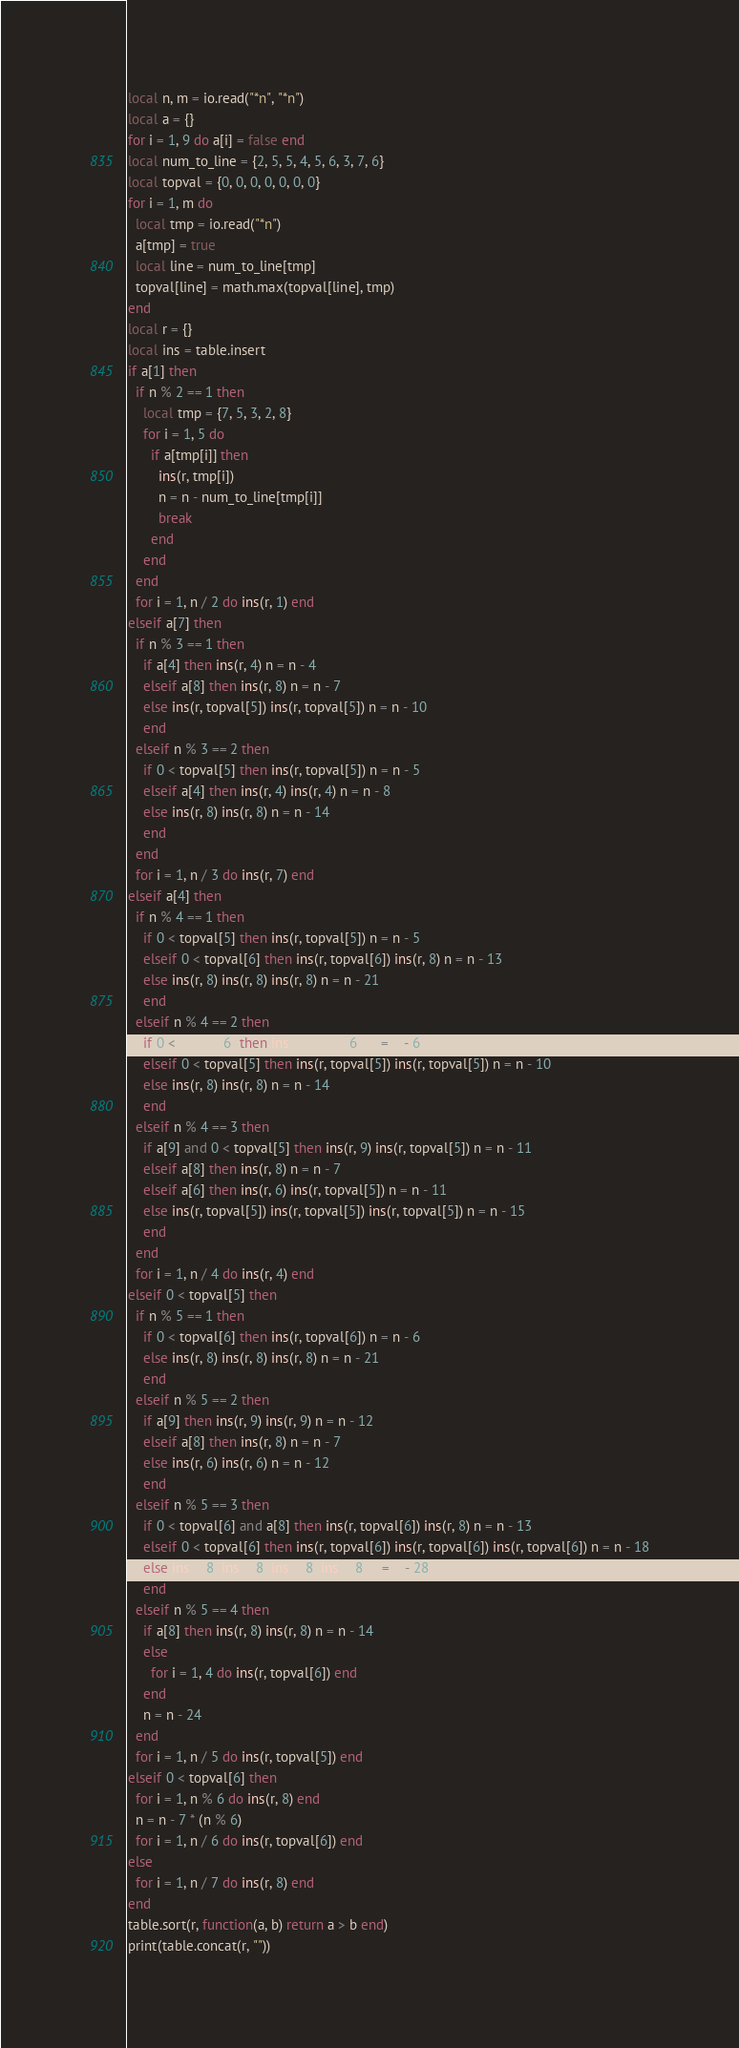<code> <loc_0><loc_0><loc_500><loc_500><_Lua_>local n, m = io.read("*n", "*n")
local a = {}
for i = 1, 9 do a[i] = false end
local num_to_line = {2, 5, 5, 4, 5, 6, 3, 7, 6}
local topval = {0, 0, 0, 0, 0, 0, 0}
for i = 1, m do
  local tmp = io.read("*n")
  a[tmp] = true
  local line = num_to_line[tmp]
  topval[line] = math.max(topval[line], tmp)
end
local r = {}
local ins = table.insert
if a[1] then
  if n % 2 == 1 then
    local tmp = {7, 5, 3, 2, 8}
    for i = 1, 5 do
      if a[tmp[i]] then
        ins(r, tmp[i])
        n = n - num_to_line[tmp[i]]
        break
      end
    end
  end
  for i = 1, n / 2 do ins(r, 1) end
elseif a[7] then
  if n % 3 == 1 then
    if a[4] then ins(r, 4) n = n - 4
    elseif a[8] then ins(r, 8) n = n - 7
    else ins(r, topval[5]) ins(r, topval[5]) n = n - 10
    end
  elseif n % 3 == 2 then
    if 0 < topval[5] then ins(r, topval[5]) n = n - 5
    elseif a[4] then ins(r, 4) ins(r, 4) n = n - 8
    else ins(r, 8) ins(r, 8) n = n - 14
    end
  end
  for i = 1, n / 3 do ins(r, 7) end
elseif a[4] then
  if n % 4 == 1 then
    if 0 < topval[5] then ins(r, topval[5]) n = n - 5
    elseif 0 < topval[6] then ins(r, topval[6]) ins(r, 8) n = n - 13
    else ins(r, 8) ins(r, 8) ins(r, 8) n = n - 21
    end
  elseif n % 4 == 2 then
    if 0 < topval[6] then ins(r, topval[6]) n = n - 6
    elseif 0 < topval[5] then ins(r, topval[5]) ins(r, topval[5]) n = n - 10
    else ins(r, 8) ins(r, 8) n = n - 14
    end
  elseif n % 4 == 3 then
    if a[9] and 0 < topval[5] then ins(r, 9) ins(r, topval[5]) n = n - 11
    elseif a[8] then ins(r, 8) n = n - 7
    elseif a[6] then ins(r, 6) ins(r, topval[5]) n = n - 11
    else ins(r, topval[5]) ins(r, topval[5]) ins(r, topval[5]) n = n - 15
    end
  end
  for i = 1, n / 4 do ins(r, 4) end
elseif 0 < topval[5] then
  if n % 5 == 1 then
    if 0 < topval[6] then ins(r, topval[6]) n = n - 6
    else ins(r, 8) ins(r, 8) ins(r, 8) n = n - 21
    end
  elseif n % 5 == 2 then
    if a[9] then ins(r, 9) ins(r, 9) n = n - 12
    elseif a[8] then ins(r, 8) n = n - 7
    else ins(r, 6) ins(r, 6) n = n - 12
    end
  elseif n % 5 == 3 then
    if 0 < topval[6] and a[8] then ins(r, topval[6]) ins(r, 8) n = n - 13
    elseif 0 < topval[6] then ins(r, topval[6]) ins(r, topval[6]) ins(r, topval[6]) n = n - 18
    else ins(r, 8) ins(r, 8) ins(r, 8) ins(r, 8) n = n - 28
    end
  elseif n % 5 == 4 then
    if a[8] then ins(r, 8) ins(r, 8) n = n - 14
    else
      for i = 1, 4 do ins(r, topval[6]) end
    end
    n = n - 24
  end
  for i = 1, n / 5 do ins(r, topval[5]) end
elseif 0 < topval[6] then
  for i = 1, n % 6 do ins(r, 8) end
  n = n - 7 * (n % 6)
  for i = 1, n / 6 do ins(r, topval[6]) end
else
  for i = 1, n / 7 do ins(r, 8) end
end
table.sort(r, function(a, b) return a > b end)
print(table.concat(r, ""))
</code> 